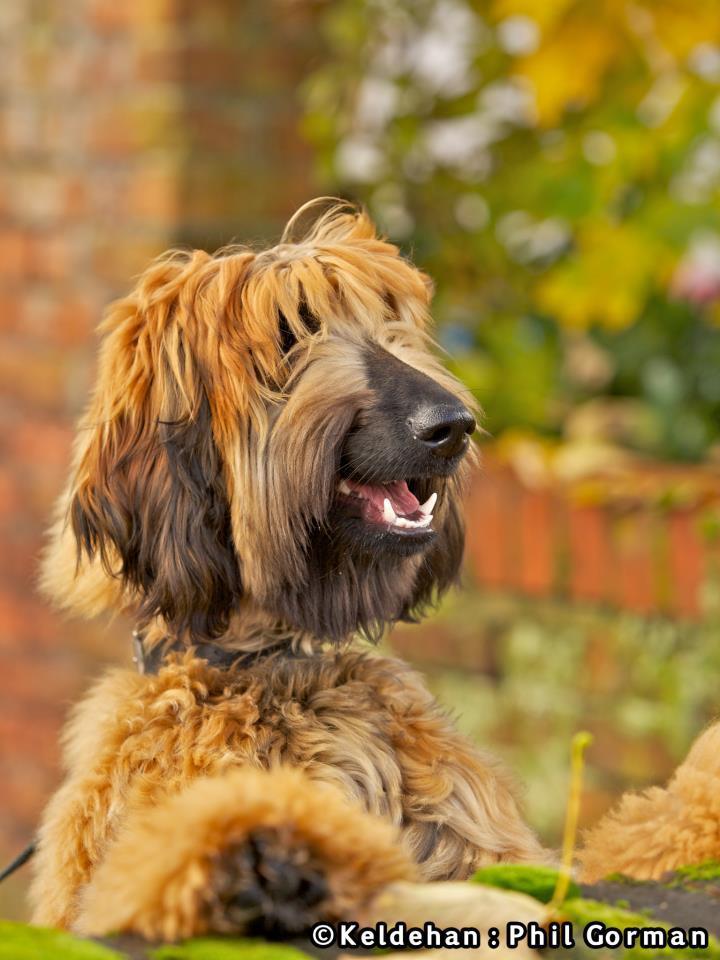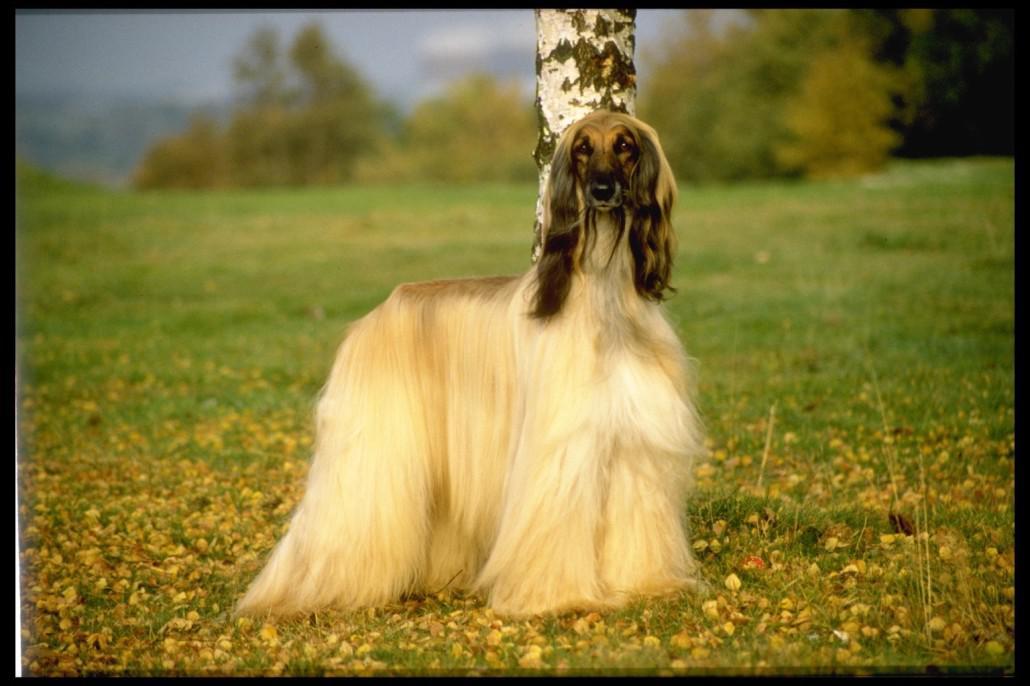The first image is the image on the left, the second image is the image on the right. Assess this claim about the two images: "A total of three afghan hounds are shown, including one hound that stands alone in an image and gazes toward the camera, and a reclining hound that is on the left of another dog in the other image.". Correct or not? Answer yes or no. No. The first image is the image on the left, the second image is the image on the right. Assess this claim about the two images: "There are 3 dogs.". Correct or not? Answer yes or no. No. 